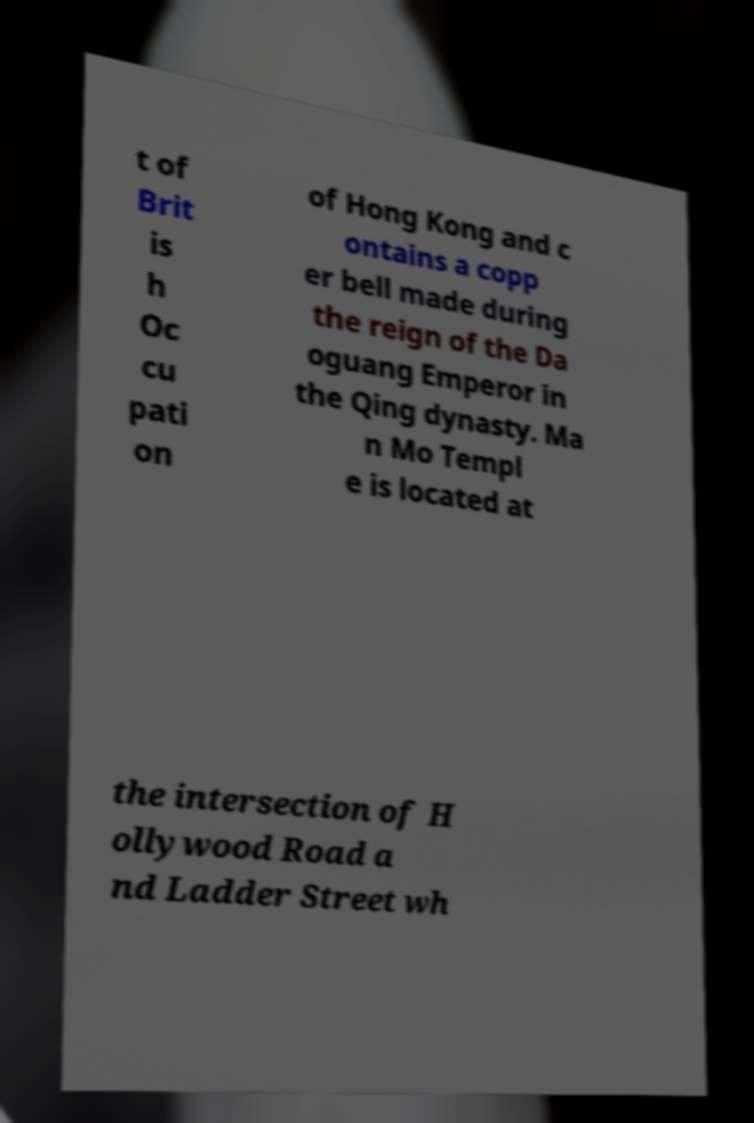There's text embedded in this image that I need extracted. Can you transcribe it verbatim? t of Brit is h Oc cu pati on of Hong Kong and c ontains a copp er bell made during the reign of the Da oguang Emperor in the Qing dynasty. Ma n Mo Templ e is located at the intersection of H ollywood Road a nd Ladder Street wh 